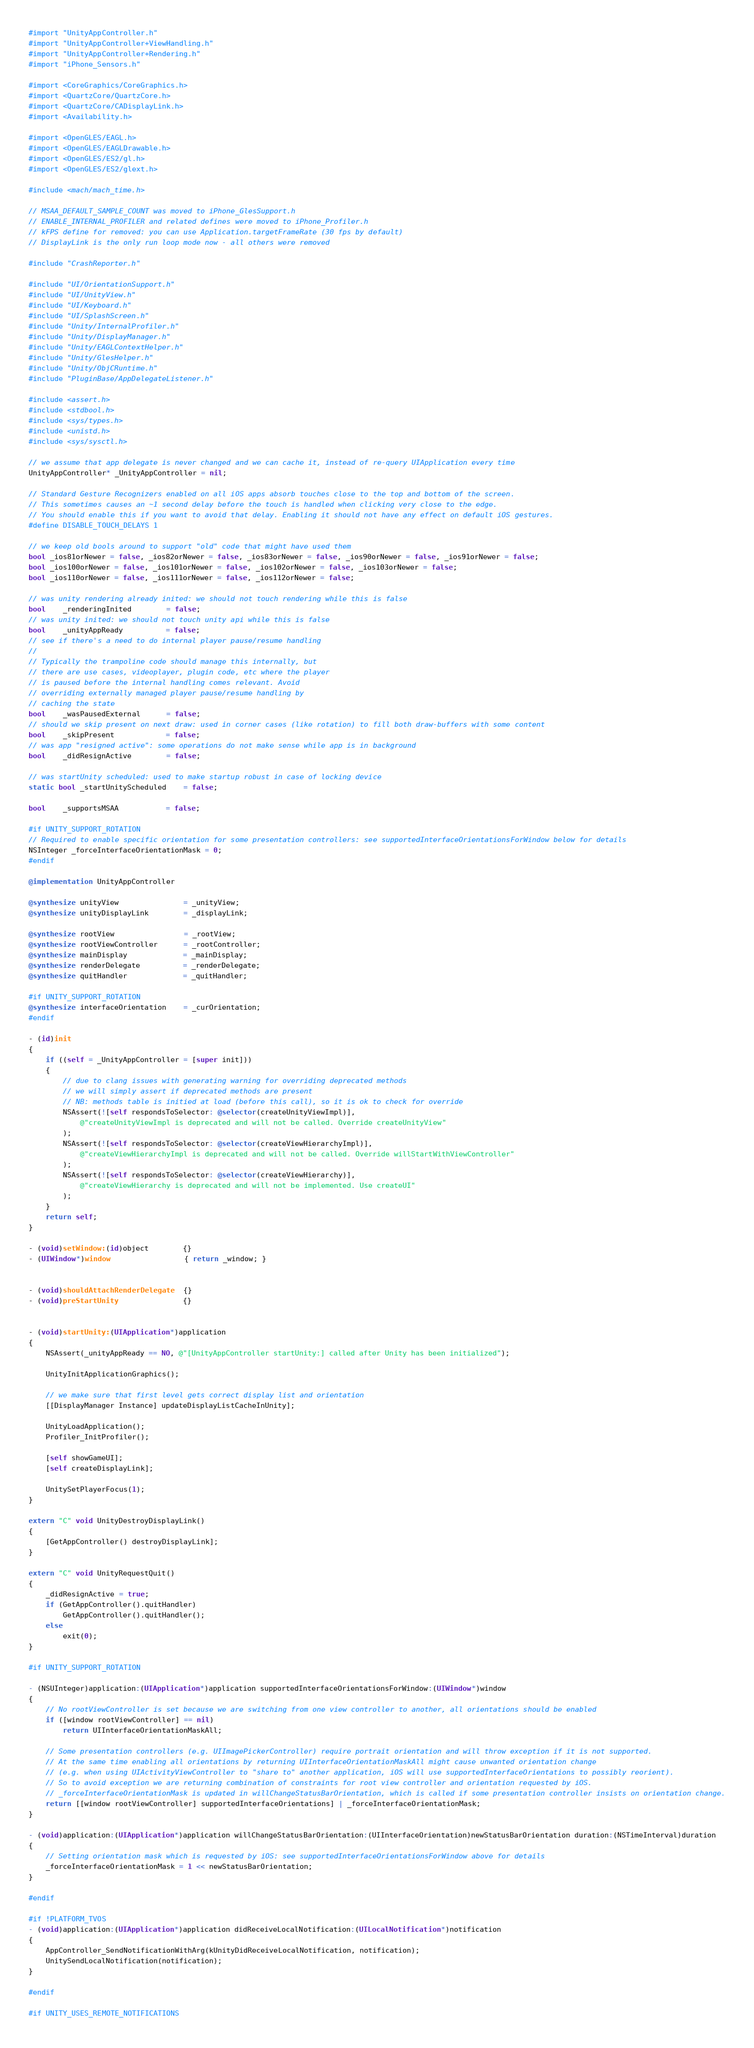Convert code to text. <code><loc_0><loc_0><loc_500><loc_500><_ObjectiveC_>#import "UnityAppController.h"
#import "UnityAppController+ViewHandling.h"
#import "UnityAppController+Rendering.h"
#import "iPhone_Sensors.h"

#import <CoreGraphics/CoreGraphics.h>
#import <QuartzCore/QuartzCore.h>
#import <QuartzCore/CADisplayLink.h>
#import <Availability.h>

#import <OpenGLES/EAGL.h>
#import <OpenGLES/EAGLDrawable.h>
#import <OpenGLES/ES2/gl.h>
#import <OpenGLES/ES2/glext.h>

#include <mach/mach_time.h>

// MSAA_DEFAULT_SAMPLE_COUNT was moved to iPhone_GlesSupport.h
// ENABLE_INTERNAL_PROFILER and related defines were moved to iPhone_Profiler.h
// kFPS define for removed: you can use Application.targetFrameRate (30 fps by default)
// DisplayLink is the only run loop mode now - all others were removed

#include "CrashReporter.h"

#include "UI/OrientationSupport.h"
#include "UI/UnityView.h"
#include "UI/Keyboard.h"
#include "UI/SplashScreen.h"
#include "Unity/InternalProfiler.h"
#include "Unity/DisplayManager.h"
#include "Unity/EAGLContextHelper.h"
#include "Unity/GlesHelper.h"
#include "Unity/ObjCRuntime.h"
#include "PluginBase/AppDelegateListener.h"

#include <assert.h>
#include <stdbool.h>
#include <sys/types.h>
#include <unistd.h>
#include <sys/sysctl.h>

// we assume that app delegate is never changed and we can cache it, instead of re-query UIApplication every time
UnityAppController* _UnityAppController = nil;

// Standard Gesture Recognizers enabled on all iOS apps absorb touches close to the top and bottom of the screen.
// This sometimes causes an ~1 second delay before the touch is handled when clicking very close to the edge.
// You should enable this if you want to avoid that delay. Enabling it should not have any effect on default iOS gestures.
#define DISABLE_TOUCH_DELAYS 1

// we keep old bools around to support "old" code that might have used them
bool _ios81orNewer = false, _ios82orNewer = false, _ios83orNewer = false, _ios90orNewer = false, _ios91orNewer = false;
bool _ios100orNewer = false, _ios101orNewer = false, _ios102orNewer = false, _ios103orNewer = false;
bool _ios110orNewer = false, _ios111orNewer = false, _ios112orNewer = false;

// was unity rendering already inited: we should not touch rendering while this is false
bool    _renderingInited        = false;
// was unity inited: we should not touch unity api while this is false
bool    _unityAppReady          = false;
// see if there's a need to do internal player pause/resume handling
//
// Typically the trampoline code should manage this internally, but
// there are use cases, videoplayer, plugin code, etc where the player
// is paused before the internal handling comes relevant. Avoid
// overriding externally managed player pause/resume handling by
// caching the state
bool    _wasPausedExternal      = false;
// should we skip present on next draw: used in corner cases (like rotation) to fill both draw-buffers with some content
bool    _skipPresent            = false;
// was app "resigned active": some operations do not make sense while app is in background
bool    _didResignActive        = false;

// was startUnity scheduled: used to make startup robust in case of locking device
static bool _startUnityScheduled    = false;

bool    _supportsMSAA           = false;

#if UNITY_SUPPORT_ROTATION
// Required to enable specific orientation for some presentation controllers: see supportedInterfaceOrientationsForWindow below for details
NSInteger _forceInterfaceOrientationMask = 0;
#endif

@implementation UnityAppController

@synthesize unityView               = _unityView;
@synthesize unityDisplayLink        = _displayLink;

@synthesize rootView                = _rootView;
@synthesize rootViewController      = _rootController;
@synthesize mainDisplay             = _mainDisplay;
@synthesize renderDelegate          = _renderDelegate;
@synthesize quitHandler             = _quitHandler;

#if UNITY_SUPPORT_ROTATION
@synthesize interfaceOrientation    = _curOrientation;
#endif

- (id)init
{
    if ((self = _UnityAppController = [super init]))
    {
        // due to clang issues with generating warning for overriding deprecated methods
        // we will simply assert if deprecated methods are present
        // NB: methods table is initied at load (before this call), so it is ok to check for override
        NSAssert(![self respondsToSelector: @selector(createUnityViewImpl)],
            @"createUnityViewImpl is deprecated and will not be called. Override createUnityView"
        );
        NSAssert(![self respondsToSelector: @selector(createViewHierarchyImpl)],
            @"createViewHierarchyImpl is deprecated and will not be called. Override willStartWithViewController"
        );
        NSAssert(![self respondsToSelector: @selector(createViewHierarchy)],
            @"createViewHierarchy is deprecated and will not be implemented. Use createUI"
        );
    }
    return self;
}

- (void)setWindow:(id)object        {}
- (UIWindow*)window                 { return _window; }


- (void)shouldAttachRenderDelegate  {}
- (void)preStartUnity               {}


- (void)startUnity:(UIApplication*)application
{
    NSAssert(_unityAppReady == NO, @"[UnityAppController startUnity:] called after Unity has been initialized");

    UnityInitApplicationGraphics();

    // we make sure that first level gets correct display list and orientation
    [[DisplayManager Instance] updateDisplayListCacheInUnity];

    UnityLoadApplication();
    Profiler_InitProfiler();

    [self showGameUI];
    [self createDisplayLink];

    UnitySetPlayerFocus(1);
}

extern "C" void UnityDestroyDisplayLink()
{
    [GetAppController() destroyDisplayLink];
}

extern "C" void UnityRequestQuit()
{
    _didResignActive = true;
    if (GetAppController().quitHandler)
        GetAppController().quitHandler();
    else
        exit(0);
}

#if UNITY_SUPPORT_ROTATION

- (NSUInteger)application:(UIApplication*)application supportedInterfaceOrientationsForWindow:(UIWindow*)window
{
    // No rootViewController is set because we are switching from one view controller to another, all orientations should be enabled
    if ([window rootViewController] == nil)
        return UIInterfaceOrientationMaskAll;

    // Some presentation controllers (e.g. UIImagePickerController) require portrait orientation and will throw exception if it is not supported.
    // At the same time enabling all orientations by returning UIInterfaceOrientationMaskAll might cause unwanted orientation change
    // (e.g. when using UIActivityViewController to "share to" another application, iOS will use supportedInterfaceOrientations to possibly reorient).
    // So to avoid exception we are returning combination of constraints for root view controller and orientation requested by iOS.
    // _forceInterfaceOrientationMask is updated in willChangeStatusBarOrientation, which is called if some presentation controller insists on orientation change.
    return [[window rootViewController] supportedInterfaceOrientations] | _forceInterfaceOrientationMask;
}

- (void)application:(UIApplication*)application willChangeStatusBarOrientation:(UIInterfaceOrientation)newStatusBarOrientation duration:(NSTimeInterval)duration
{
    // Setting orientation mask which is requested by iOS: see supportedInterfaceOrientationsForWindow above for details
    _forceInterfaceOrientationMask = 1 << newStatusBarOrientation;
}

#endif

#if !PLATFORM_TVOS
- (void)application:(UIApplication*)application didReceiveLocalNotification:(UILocalNotification*)notification
{
    AppController_SendNotificationWithArg(kUnityDidReceiveLocalNotification, notification);
    UnitySendLocalNotification(notification);
}

#endif

#if UNITY_USES_REMOTE_NOTIFICATIONS</code> 